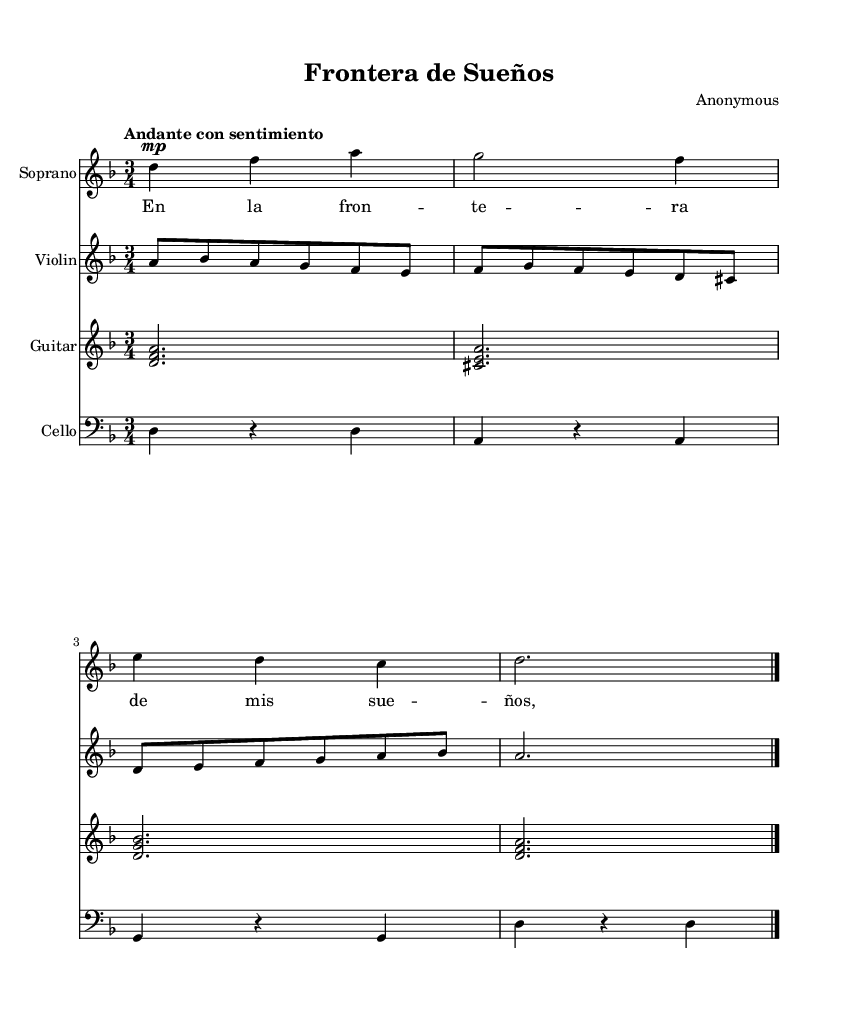What is the key signature of this music? The key signature is D minor, which includes one flat (B flat). You can identify this by looking at the key signature section at the beginning of the score.
Answer: D minor What is the time signature of this music? The time signature is 3/4, indicating that there are three beats per measure and the quarter note gets one beat. It can be found at the beginning of the score next to the key signature.
Answer: 3/4 What tempo is indicated for the piece? The tempo marking is "Andante con sentimiento," which suggests a moderate pace with feeling. This is noted above the staff at the beginning of the score.
Answer: Andante con sentimiento How many instruments are included in this score? The score features four instruments: Soprano, Violin, Guitar, and Cello. You can see the staff labels at the beginning of each section in the score.
Answer: Four What is the first note of the soprano voice? The first note of the soprano voice is D, identified as the note at the beginning of the soprano staff, which also corresponds with the key signature.
Answer: D How many notes are in the cello part? There are four distinct notes in the cello part. This can be counted directly from the written notes in the bass clef for the cello.
Answer: Four What is the main theme expressed in the soprano lyrics? The main theme in the soprano lyrics involves dreams at the border, signifying emotional and cultural struggles. This idea is derived directly from the lyrics provided for the soprano voice.
Answer: Dreams at the border 